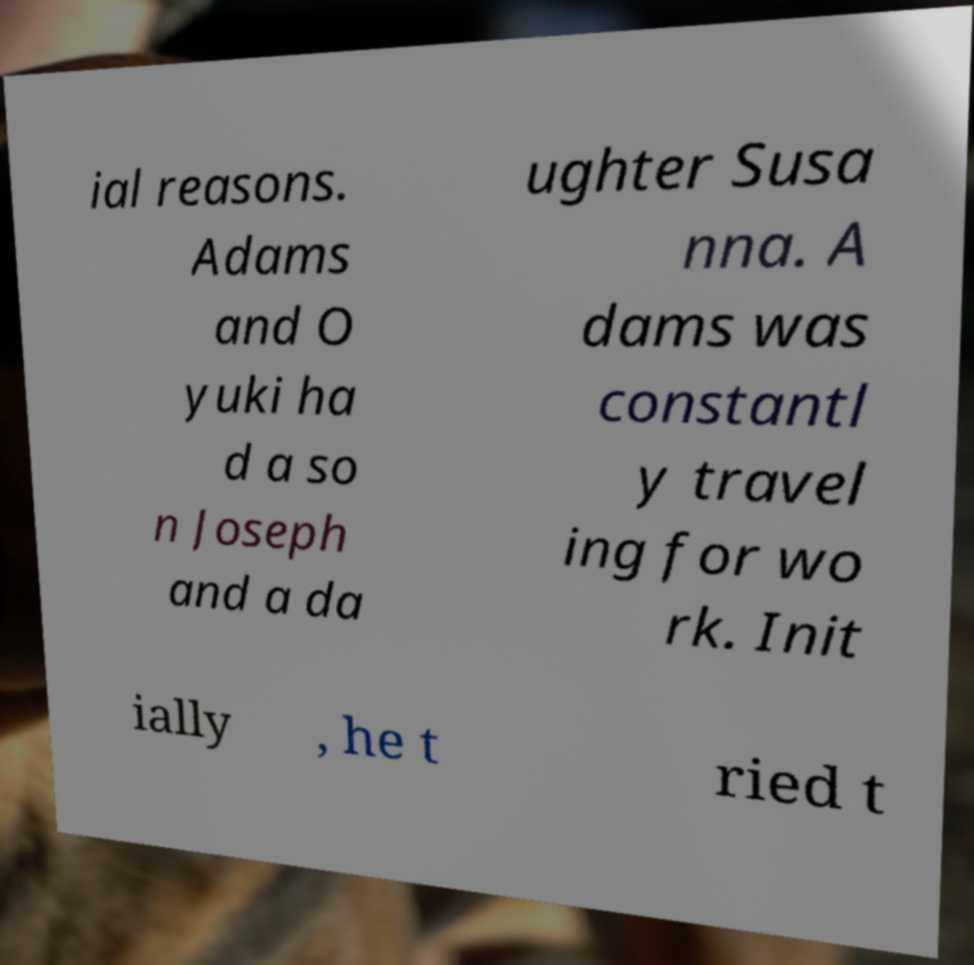Can you read and provide the text displayed in the image?This photo seems to have some interesting text. Can you extract and type it out for me? ial reasons. Adams and O yuki ha d a so n Joseph and a da ughter Susa nna. A dams was constantl y travel ing for wo rk. Init ially , he t ried t 